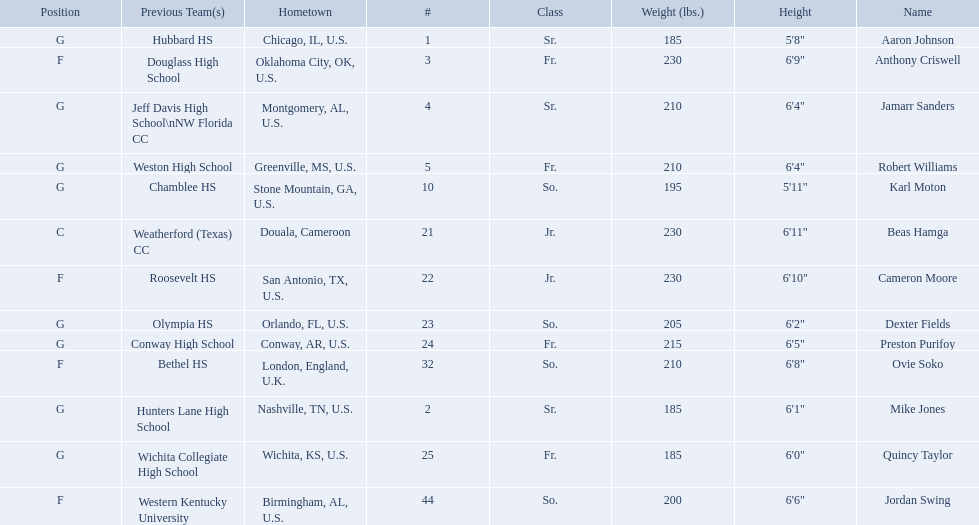Who are all the players? Aaron Johnson, Anthony Criswell, Jamarr Sanders, Robert Williams, Karl Moton, Beas Hamga, Cameron Moore, Dexter Fields, Preston Purifoy, Ovie Soko, Mike Jones, Quincy Taylor, Jordan Swing. Of these, which are not soko? Aaron Johnson, Anthony Criswell, Jamarr Sanders, Robert Williams, Karl Moton, Beas Hamga, Cameron Moore, Dexter Fields, Preston Purifoy, Mike Jones, Quincy Taylor, Jordan Swing. Where are these players from? Sr., Fr., Sr., Fr., So., Jr., Jr., So., Fr., Sr., Fr., So. Of these locations, which are not in the u.s.? Jr. Which player is from this location? Beas Hamga. 